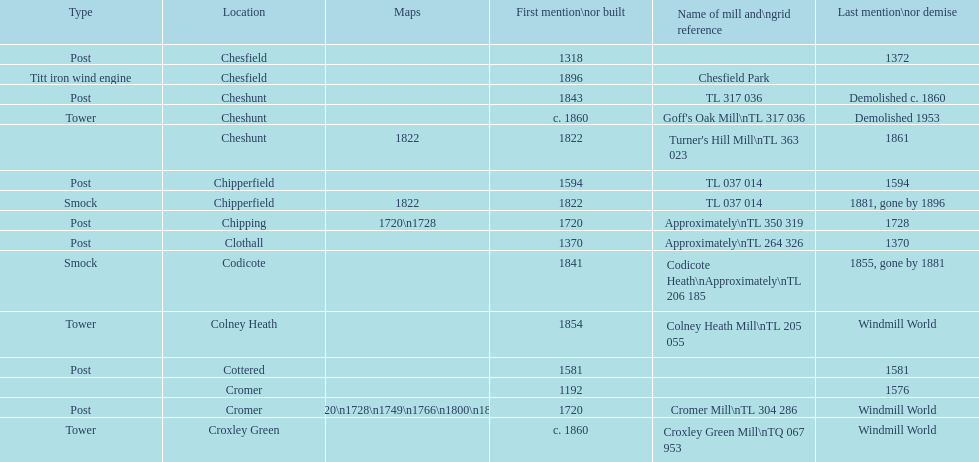Could you parse the entire table? {'header': ['Type', 'Location', 'Maps', 'First mention\\nor built', 'Name of mill and\\ngrid reference', 'Last mention\\nor demise'], 'rows': [['Post', 'Chesfield', '', '1318', '', '1372'], ['Titt iron wind engine', 'Chesfield', '', '1896', 'Chesfield Park', ''], ['Post', 'Cheshunt', '', '1843', 'TL 317 036', 'Demolished c. 1860'], ['Tower', 'Cheshunt', '', 'c. 1860', "Goff's Oak Mill\\nTL 317 036", 'Demolished 1953'], ['', 'Cheshunt', '1822', '1822', "Turner's Hill Mill\\nTL 363 023", '1861'], ['Post', 'Chipperfield', '', '1594', 'TL 037 014', '1594'], ['Smock', 'Chipperfield', '1822', '1822', 'TL 037 014', '1881, gone by 1896'], ['Post', 'Chipping', '1720\\n1728', '1720', 'Approximately\\nTL 350 319', '1728'], ['Post', 'Clothall', '', '1370', 'Approximately\\nTL 264 326', '1370'], ['Smock', 'Codicote', '', '1841', 'Codicote Heath\\nApproximately\\nTL 206 185', '1855, gone by 1881'], ['Tower', 'Colney Heath', '', '1854', 'Colney Heath Mill\\nTL 205 055', 'Windmill World'], ['Post', 'Cottered', '', '1581', '', '1581'], ['', 'Cromer', '', '1192', '', '1576'], ['Post', 'Cromer', '1720\\n1728\\n1749\\n1766\\n1800\\n1822', '1720', 'Cromer Mill\\nTL 304 286', 'Windmill World'], ['Tower', 'Croxley Green', '', 'c. 1860', 'Croxley Green Mill\\nTQ 067 953', 'Windmill World']]} What is the number of mills first mentioned or built in the 1800s? 8. 